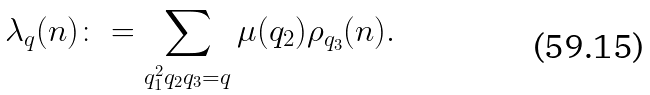Convert formula to latex. <formula><loc_0><loc_0><loc_500><loc_500>\lambda _ { q } ( n ) \colon = \sum _ { q _ { 1 } ^ { 2 } q _ { 2 } q _ { 3 } = q } \mu ( q _ { 2 } ) \rho _ { q _ { 3 } } ( n ) .</formula> 